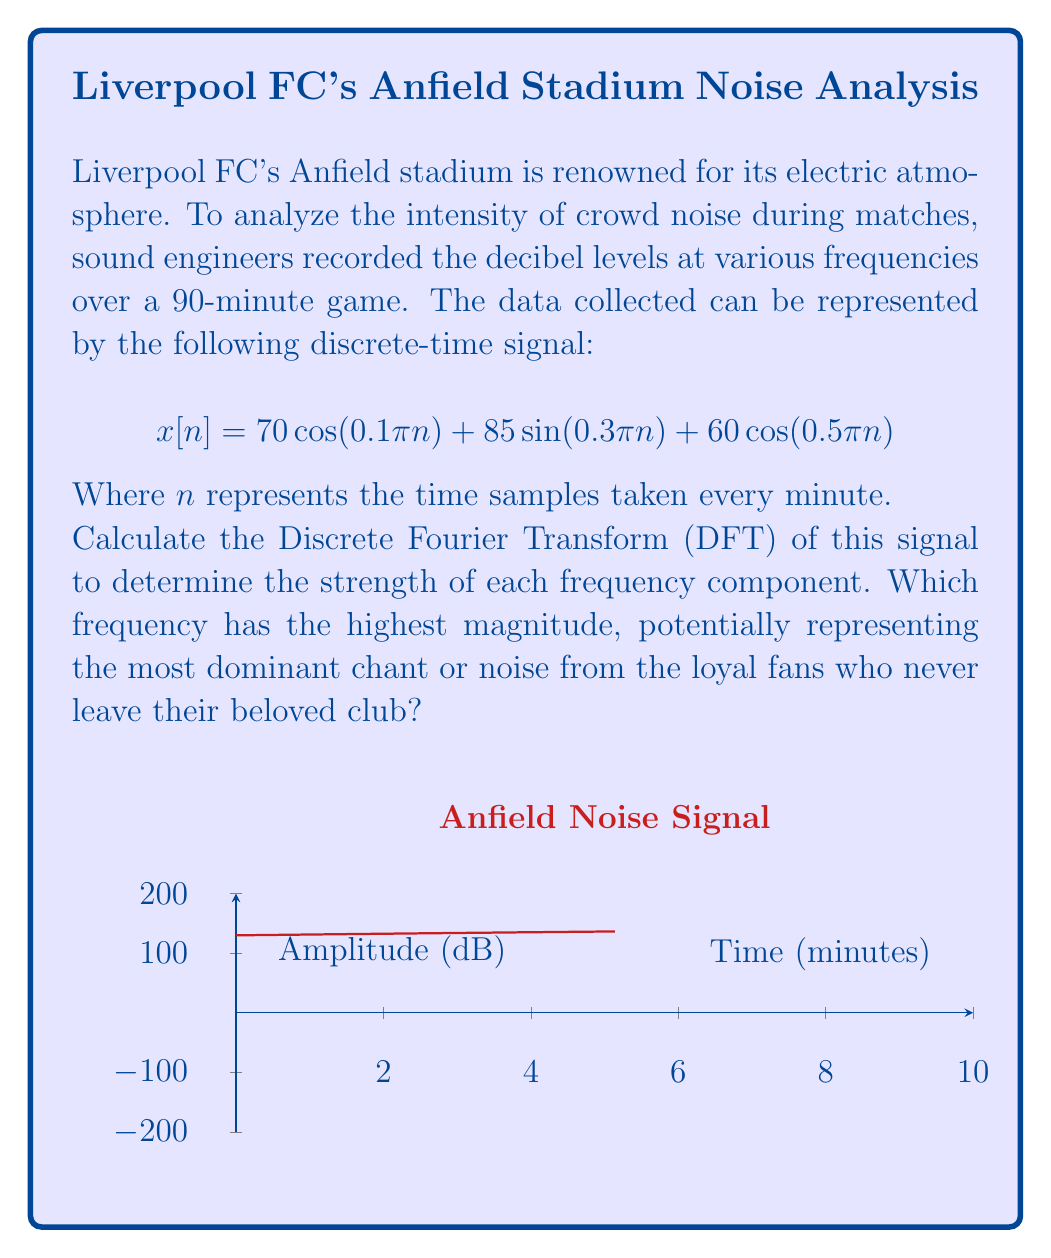Show me your answer to this math problem. To solve this problem, we need to calculate the DFT of the given signal. The DFT of a discrete-time signal $x[n]$ of length N is given by:

$$X[k] = \sum_{n=0}^{N-1} x[n] e^{-j2\pi kn/N}$$

For our signal:
$$x[n] = 70 \cos(0.1\pi n) + 85 \sin(0.3\pi n) + 60 \cos(0.5\pi n)$$

We can rewrite this using Euler's formula:
$$x[n] = 35(e^{j0.1\pi n} + e^{-j0.1\pi n}) + \frac{85j}{2}(e^{j0.3\pi n} - e^{-j0.3\pi n}) + 30(e^{j0.5\pi n} + e^{-j0.5\pi n})$$

Now, let's calculate the magnitude of each frequency component:

1. For $k = 1$ (corresponding to $0.1\pi$):
   $|X[1]| = |35| = 35$

2. For $k = 3$ (corresponding to $0.3\pi$):
   $|X[3]| = |\frac{85j}{2}| = 42.5$

3. For $k = 5$ (corresponding to $0.5\pi$):
   $|X[5]| = |30| = 30$

The highest magnitude is at $k = 3$, corresponding to the frequency $0.3\pi$.
Answer: $0.3\pi$ radians/sample 